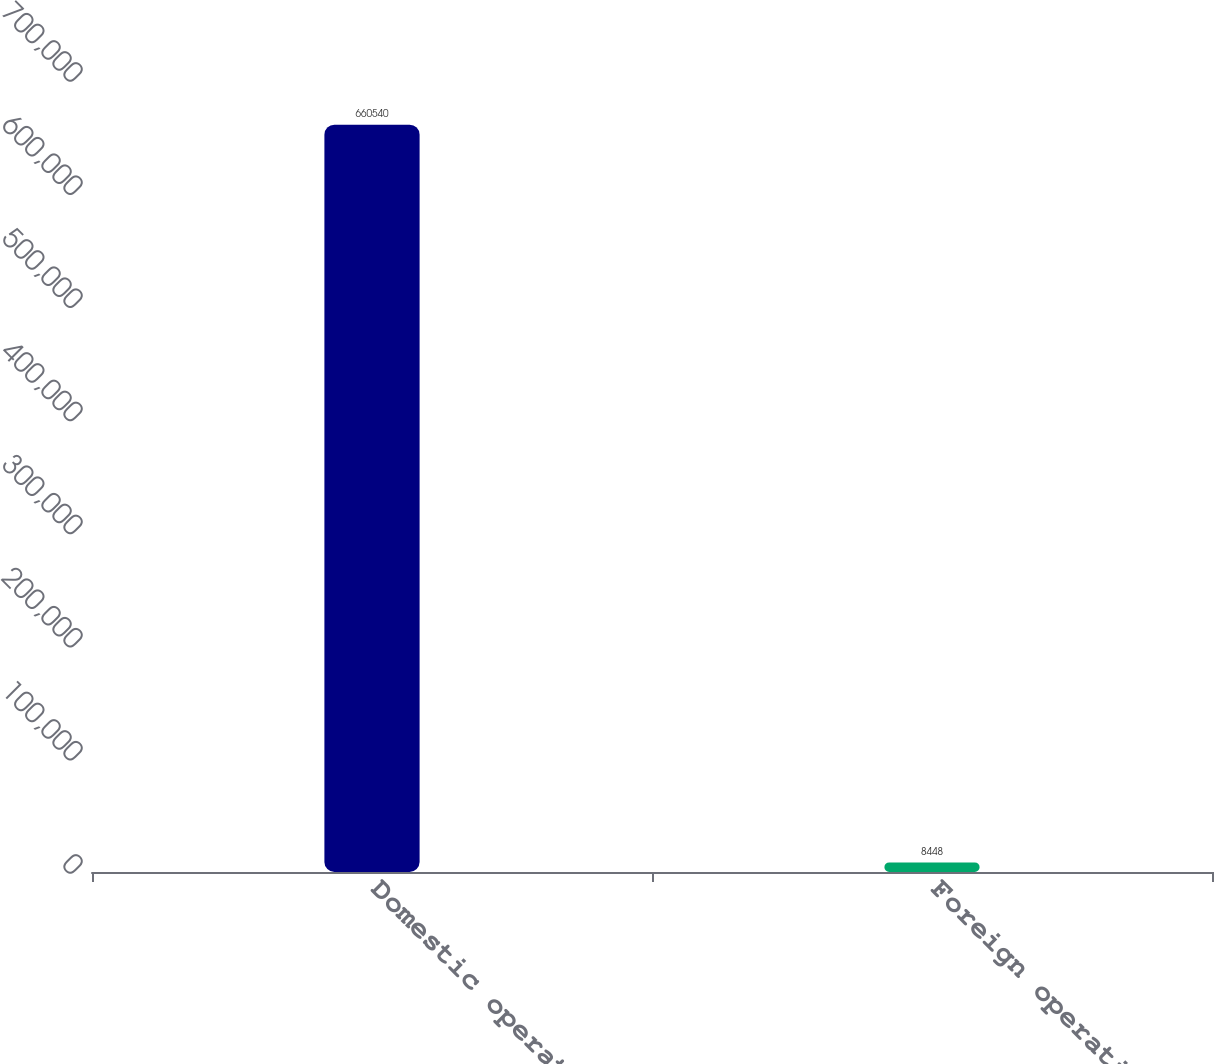Convert chart to OTSL. <chart><loc_0><loc_0><loc_500><loc_500><bar_chart><fcel>Domestic operations<fcel>Foreign operations<nl><fcel>660540<fcel>8448<nl></chart> 